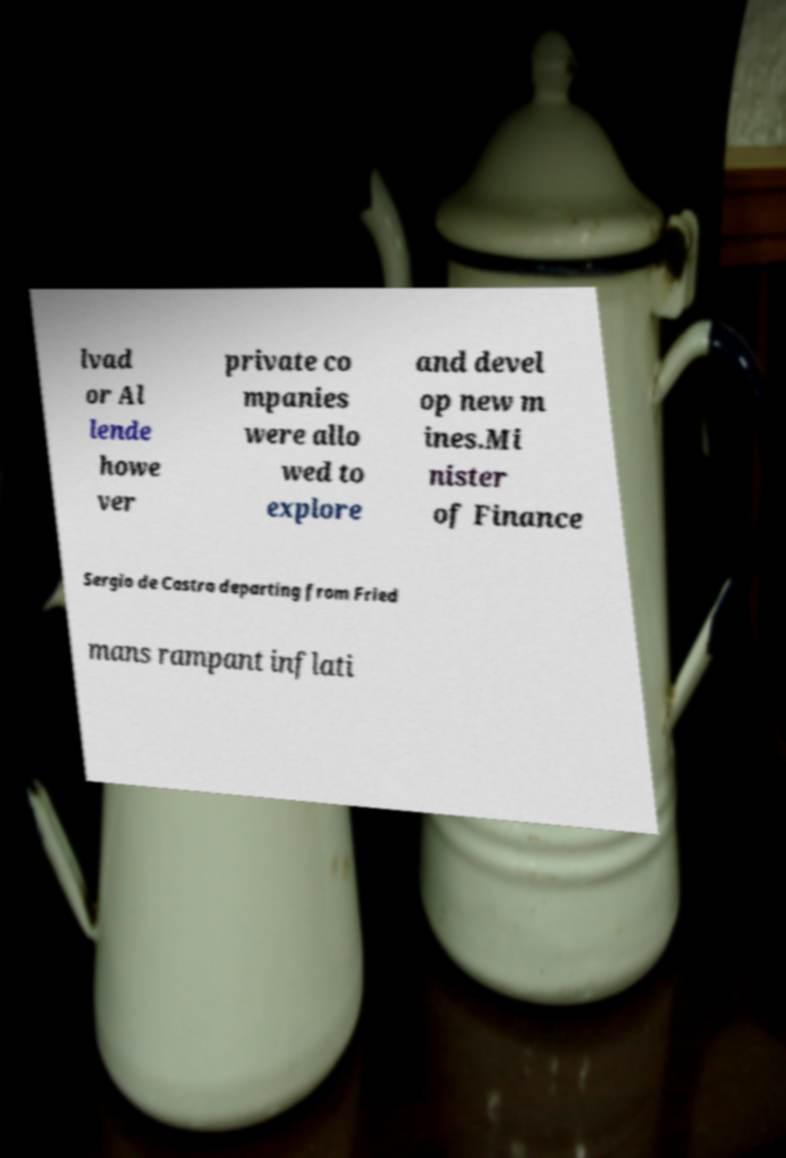Could you extract and type out the text from this image? lvad or Al lende howe ver private co mpanies were allo wed to explore and devel op new m ines.Mi nister of Finance Sergio de Castro departing from Fried mans rampant inflati 